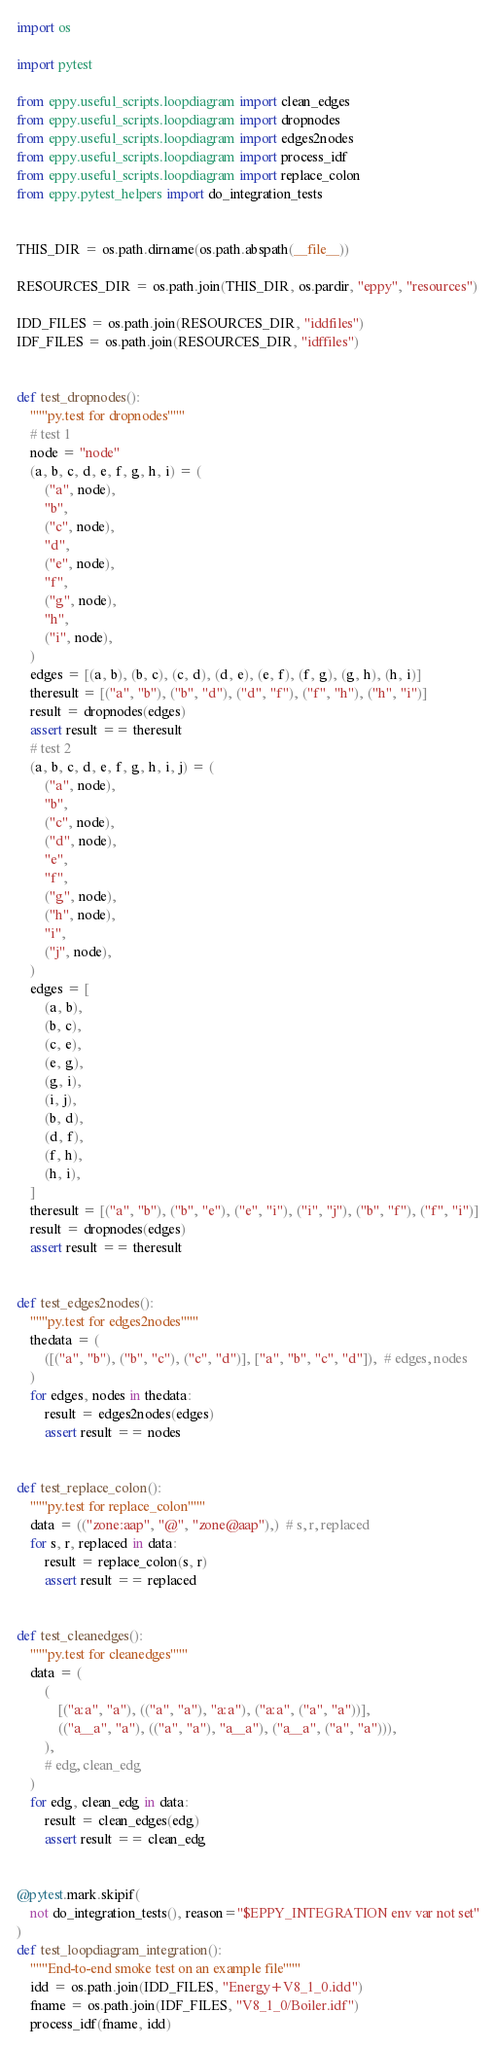<code> <loc_0><loc_0><loc_500><loc_500><_Python_>
import os

import pytest

from eppy.useful_scripts.loopdiagram import clean_edges
from eppy.useful_scripts.loopdiagram import dropnodes
from eppy.useful_scripts.loopdiagram import edges2nodes
from eppy.useful_scripts.loopdiagram import process_idf
from eppy.useful_scripts.loopdiagram import replace_colon
from eppy.pytest_helpers import do_integration_tests


THIS_DIR = os.path.dirname(os.path.abspath(__file__))

RESOURCES_DIR = os.path.join(THIS_DIR, os.pardir, "eppy", "resources")

IDD_FILES = os.path.join(RESOURCES_DIR, "iddfiles")
IDF_FILES = os.path.join(RESOURCES_DIR, "idffiles")


def test_dropnodes():
    """py.test for dropnodes"""
    # test 1
    node = "node"
    (a, b, c, d, e, f, g, h, i) = (
        ("a", node),
        "b",
        ("c", node),
        "d",
        ("e", node),
        "f",
        ("g", node),
        "h",
        ("i", node),
    )
    edges = [(a, b), (b, c), (c, d), (d, e), (e, f), (f, g), (g, h), (h, i)]
    theresult = [("a", "b"), ("b", "d"), ("d", "f"), ("f", "h"), ("h", "i")]
    result = dropnodes(edges)
    assert result == theresult
    # test 2
    (a, b, c, d, e, f, g, h, i, j) = (
        ("a", node),
        "b",
        ("c", node),
        ("d", node),
        "e",
        "f",
        ("g", node),
        ("h", node),
        "i",
        ("j", node),
    )
    edges = [
        (a, b),
        (b, c),
        (c, e),
        (e, g),
        (g, i),
        (i, j),
        (b, d),
        (d, f),
        (f, h),
        (h, i),
    ]
    theresult = [("a", "b"), ("b", "e"), ("e", "i"), ("i", "j"), ("b", "f"), ("f", "i")]
    result = dropnodes(edges)
    assert result == theresult


def test_edges2nodes():
    """py.test for edges2nodes"""
    thedata = (
        ([("a", "b"), ("b", "c"), ("c", "d")], ["a", "b", "c", "d"]),  # edges, nodes
    )
    for edges, nodes in thedata:
        result = edges2nodes(edges)
        assert result == nodes


def test_replace_colon():
    """py.test for replace_colon"""
    data = (("zone:aap", "@", "zone@aap"),)  # s, r, replaced
    for s, r, replaced in data:
        result = replace_colon(s, r)
        assert result == replaced


def test_cleanedges():
    """py.test for cleanedges"""
    data = (
        (
            [("a:a", "a"), (("a", "a"), "a:a"), ("a:a", ("a", "a"))],
            (("a__a", "a"), (("a", "a"), "a__a"), ("a__a", ("a", "a"))),
        ),
        # edg, clean_edg
    )
    for edg, clean_edg in data:
        result = clean_edges(edg)
        assert result == clean_edg


@pytest.mark.skipif(
    not do_integration_tests(), reason="$EPPY_INTEGRATION env var not set"
)
def test_loopdiagram_integration():
    """End-to-end smoke test on an example file"""
    idd = os.path.join(IDD_FILES, "Energy+V8_1_0.idd")
    fname = os.path.join(IDF_FILES, "V8_1_0/Boiler.idf")
    process_idf(fname, idd)
</code> 